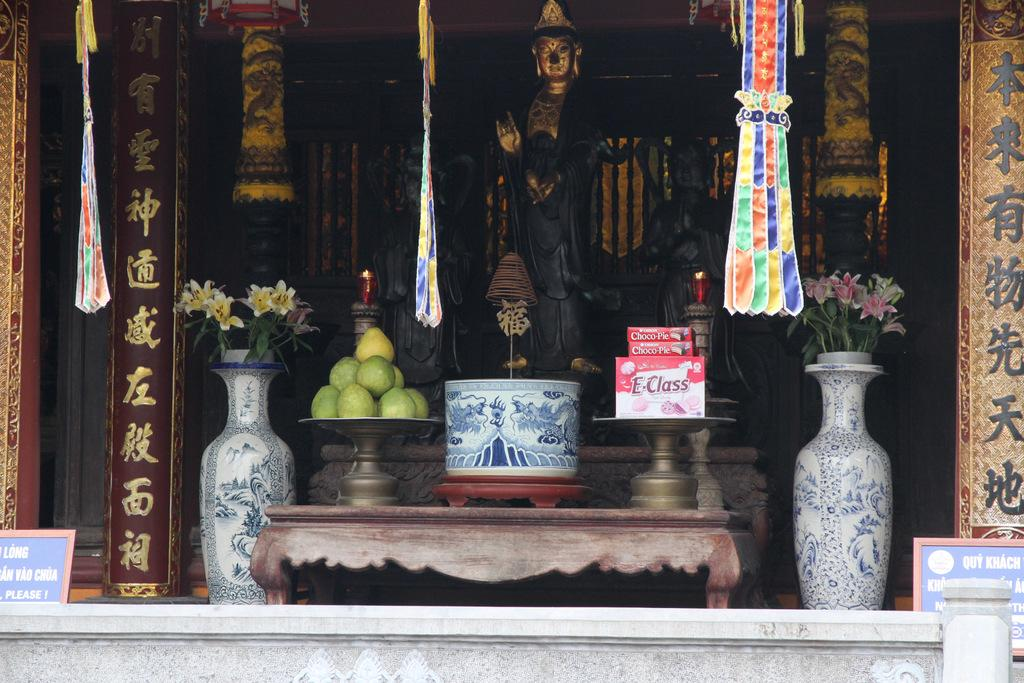What is the main subject of the image? There is a statue at the center of the image. What can be seen in front of the statue? There are objects in front of the statue. What is placed on both sides of the statue? There are flower pots on both sides of the statue. What is visible in the background of the image? There is a wall in the background of the image. What type of furniture is being argued over in the image? There is no furniture or argument present in the image; it features a statue with objects and flower pots around it, and a wall in the background. 